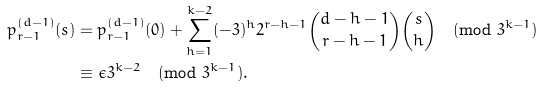Convert formula to latex. <formula><loc_0><loc_0><loc_500><loc_500>p _ { r - 1 } ^ { ( d - 1 ) } ( s ) & = p _ { r - 1 } ^ { ( d - 1 ) } ( 0 ) + \sum _ { h = 1 } ^ { k - 2 } ( - 3 ) ^ { h } 2 ^ { r - h - 1 } \binom { d - h - 1 } { r - h - 1 } \binom { s } { h } \pmod { 3 ^ { k - 1 } } \\ & \equiv \epsilon 3 ^ { k - 2 } \pmod { 3 ^ { k - 1 } } .</formula> 